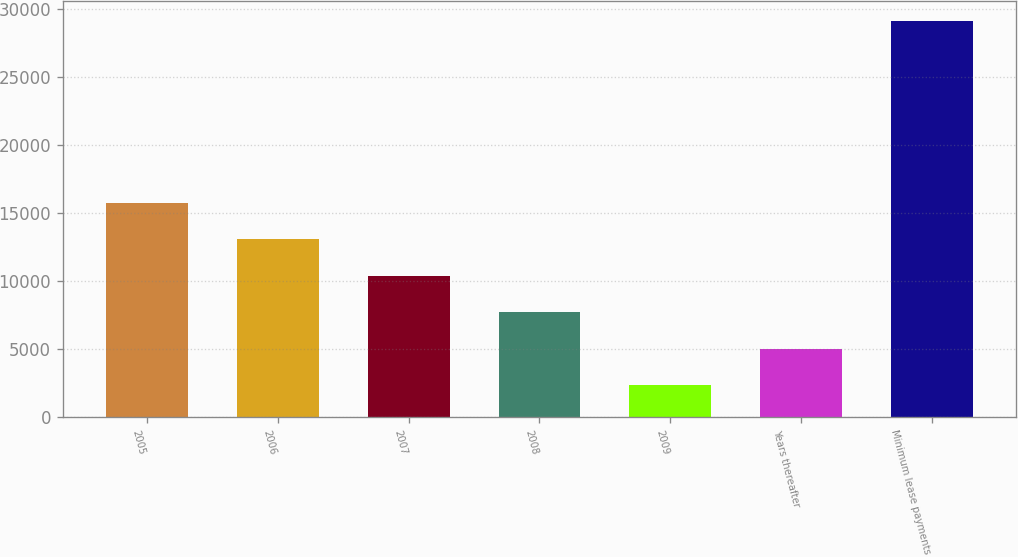<chart> <loc_0><loc_0><loc_500><loc_500><bar_chart><fcel>2005<fcel>2006<fcel>2007<fcel>2008<fcel>2009<fcel>Years thereafter<fcel>Minimum lease payments<nl><fcel>15746<fcel>13066<fcel>10386<fcel>7706<fcel>2346<fcel>5026<fcel>29146<nl></chart> 